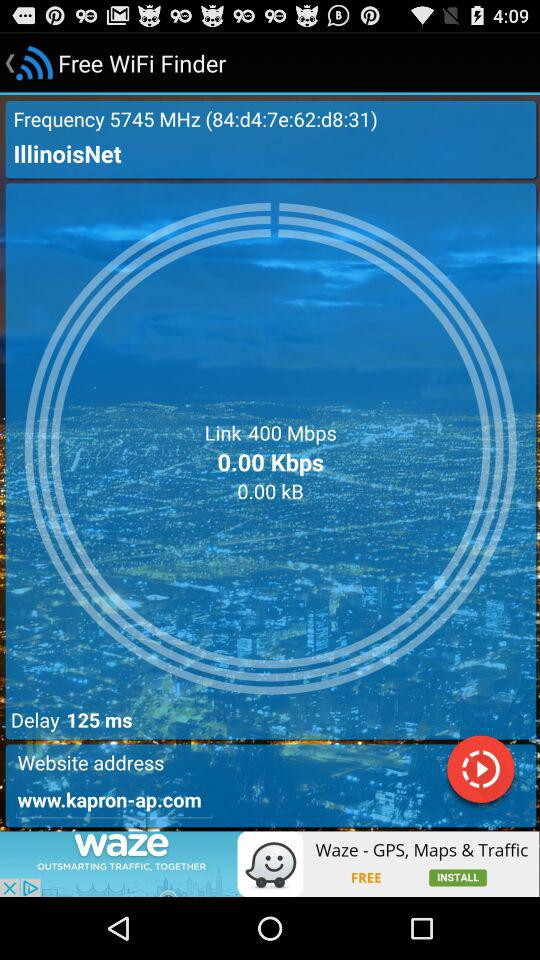What is the website address? The website address is www.kapron-ap.com. 